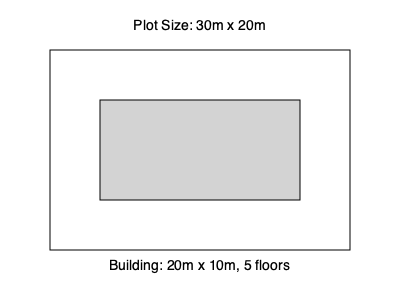A new development project in District 2 of Ho Chi Minh City involves a building with dimensions 20m x 10m and 5 floors on a plot of land measuring 30m x 20m. Calculate the Floor Area Ratio (FAR) for this project. To calculate the Floor Area Ratio (FAR), we need to follow these steps:

1. Calculate the total floor area of the building:
   - Building footprint = 20m × 10m = 200 m²
   - Number of floors = 5
   - Total floor area = 200 m² × 5 = 1000 m²

2. Calculate the plot area:
   - Plot dimensions = 30m × 20m
   - Plot area = 30m × 20m = 600 m²

3. Calculate the FAR:
   $$ FAR = \frac{\text{Total Floor Area}}{\text{Plot Area}} $$
   $$ FAR = \frac{1000 \text{ m}^2}{600 \text{ m}^2} = \frac{5}{3} \approx 1.67 $$

The Floor Area Ratio (FAR) for this project is approximately 1.67, which means the total floor area of the building is 1.67 times the size of the plot area.
Answer: 1.67 